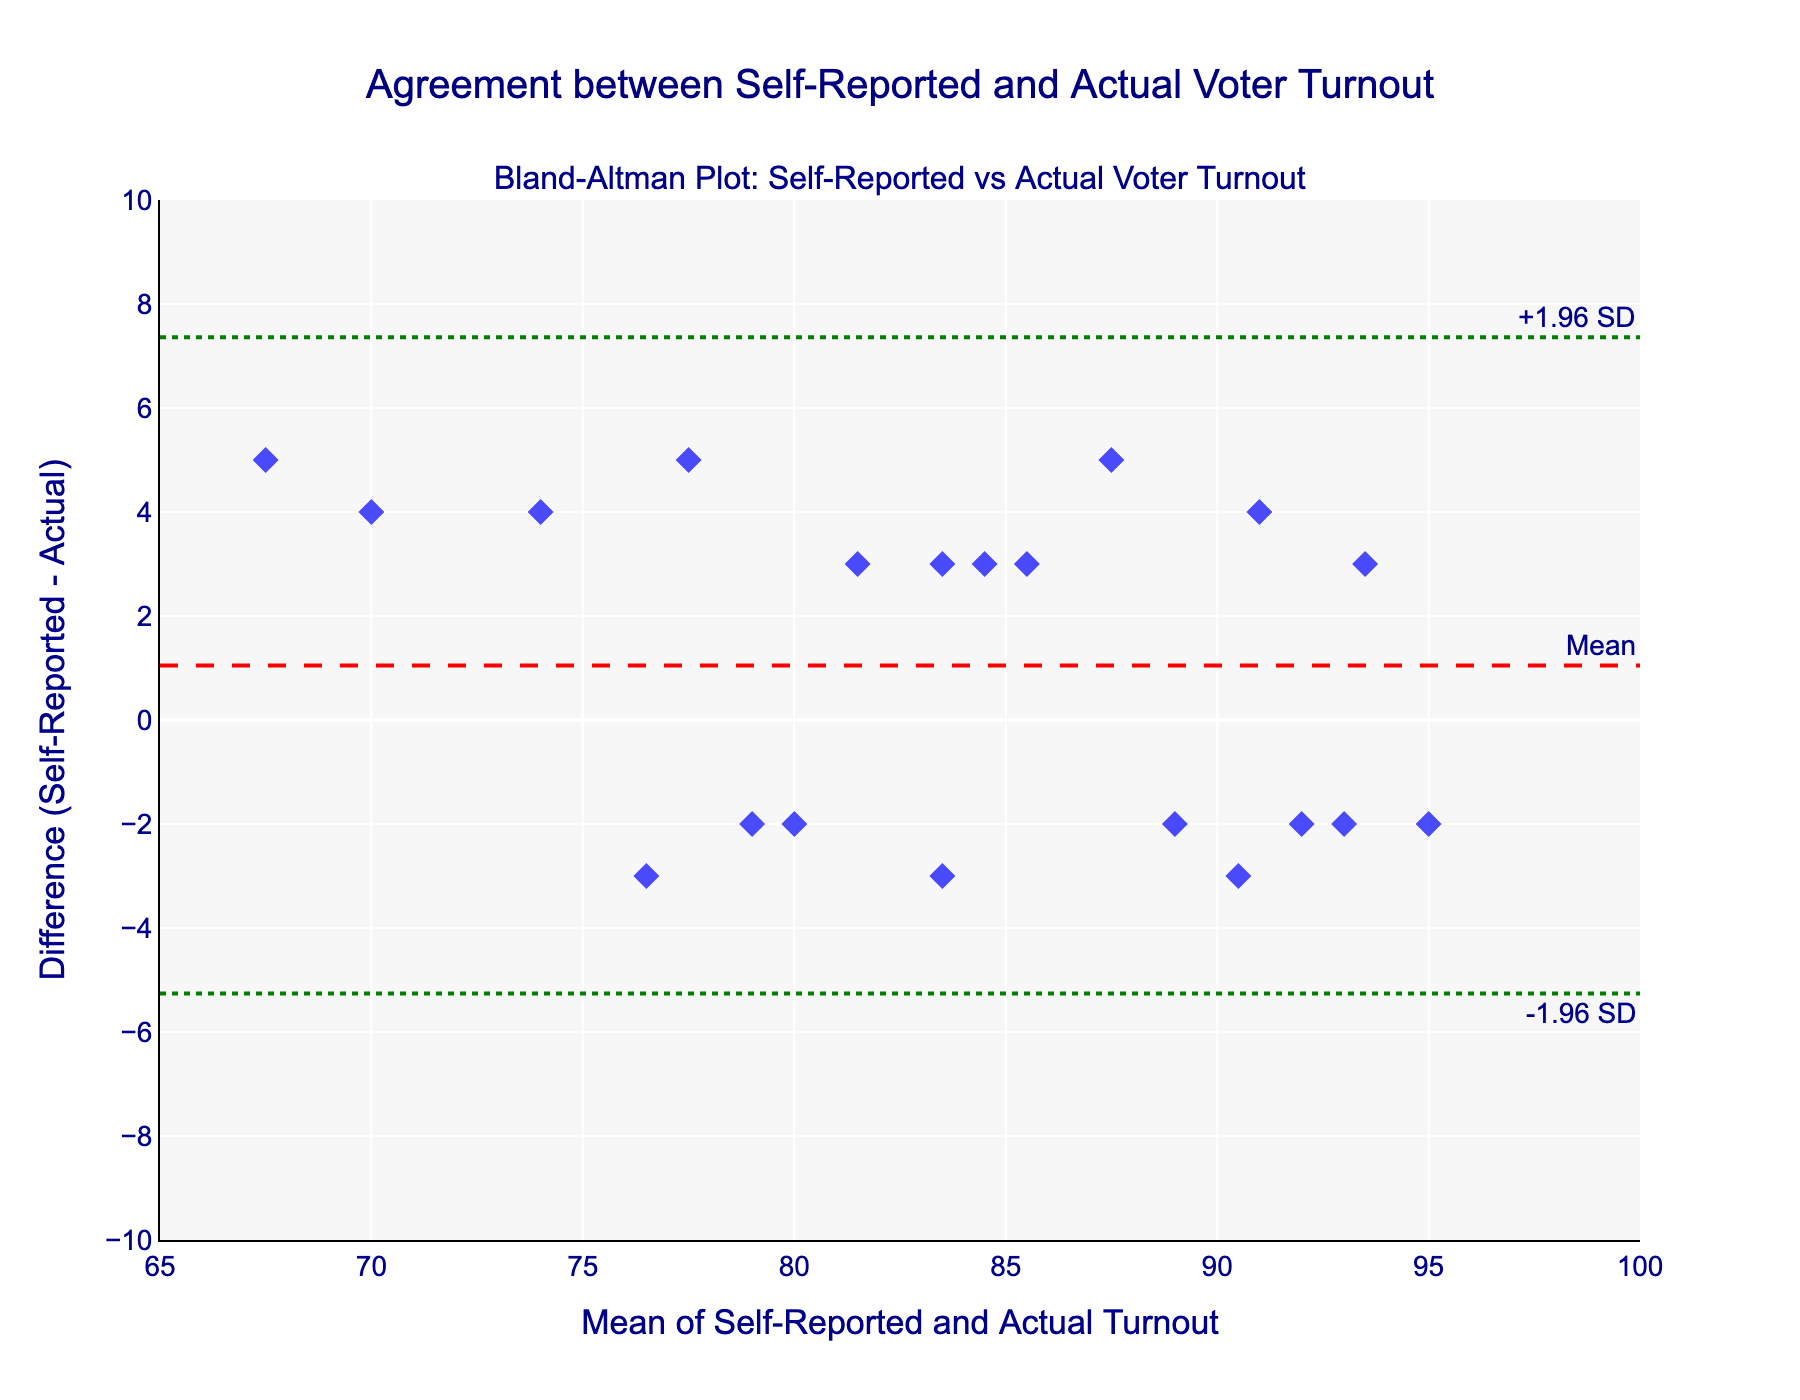What is the title of the plot? The title is located at the top center of the figure and states the main purpose of the visualization.
Answer: Agreement between Self-Reported and Actual Voter Turnout How many data points are there in the plot? Count the number of markers (diamonds) in the scatter plot visually.
Answer: 20 What is the range of the x-axis? Check the values along the x-axis to identify the minimum and maximum range.
Answer: 65 to 100 What color are the markers in the scatter plot? Look at the markers representing the data points, observing their fill color.
Answer: Blue What does the dashed red line represent? The legend or label near the dashed red line indicates its meaning.
Answer: Mean What is the mean difference between self-reported and actual voter turnout? Locate the dashed red line's y-value, which represents the mean difference.
Answer: 0.7 What are the limits of agreement? Find the green dotted lines annotated as "-1.96 SD" and "+1.96 SD" and read off their y-values.
Answer: -2.85 and 4.25 Is there a general trend in the differences as the mean turnout increases? Observe whether the differences (y-axis values) are clustering around any trend as you move along the x-axis.
Answer: No obvious trend Which data point shows the largest positive difference between self-reported and actual turnout? Identify the marker furthest above the mean line, noting down its y-value (difference) and corresponding x-value (mean).
Answer: Voter ID 4 What is the most common range of the differences between self-reported and actual turnout? Observe the vertical distribution of most points around the mean, identifying where most points fall.
Answer: -2 to 3 